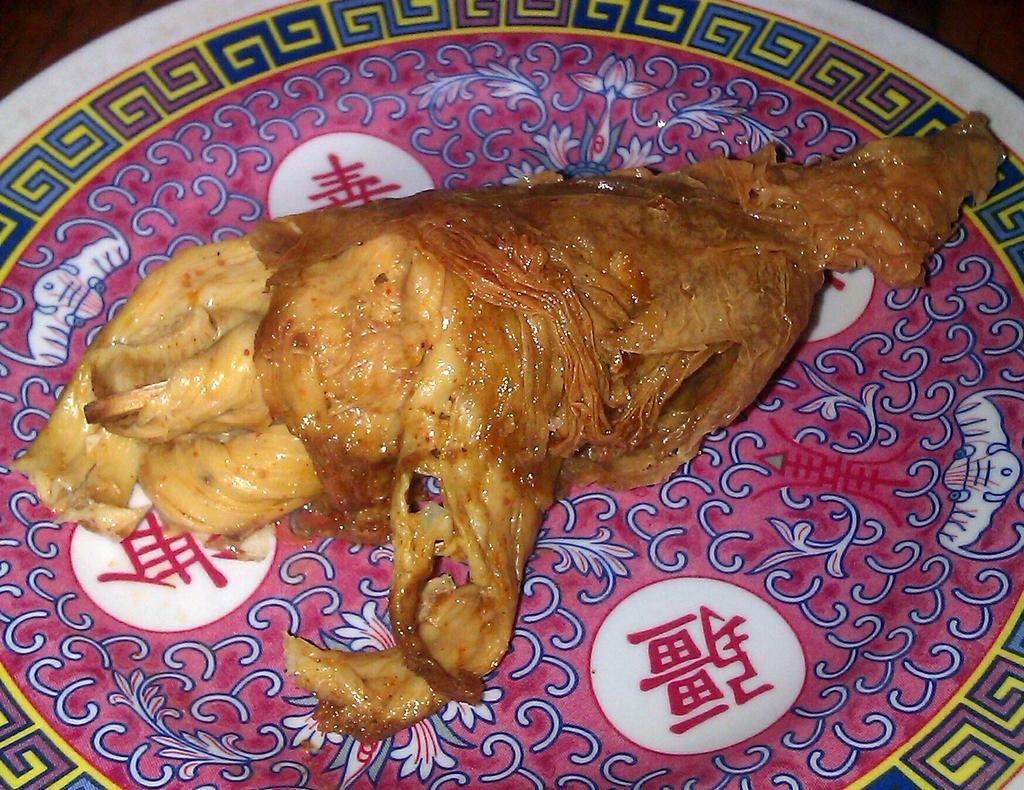What is the main object in the center of the image? There is a platter in the center of the image. What is on the platter? The platter contains a food item. Is there a zipper on the food item on the platter? No, there is no zipper on the food item on the platter, as the food item is not a garment or object with a zipper. 